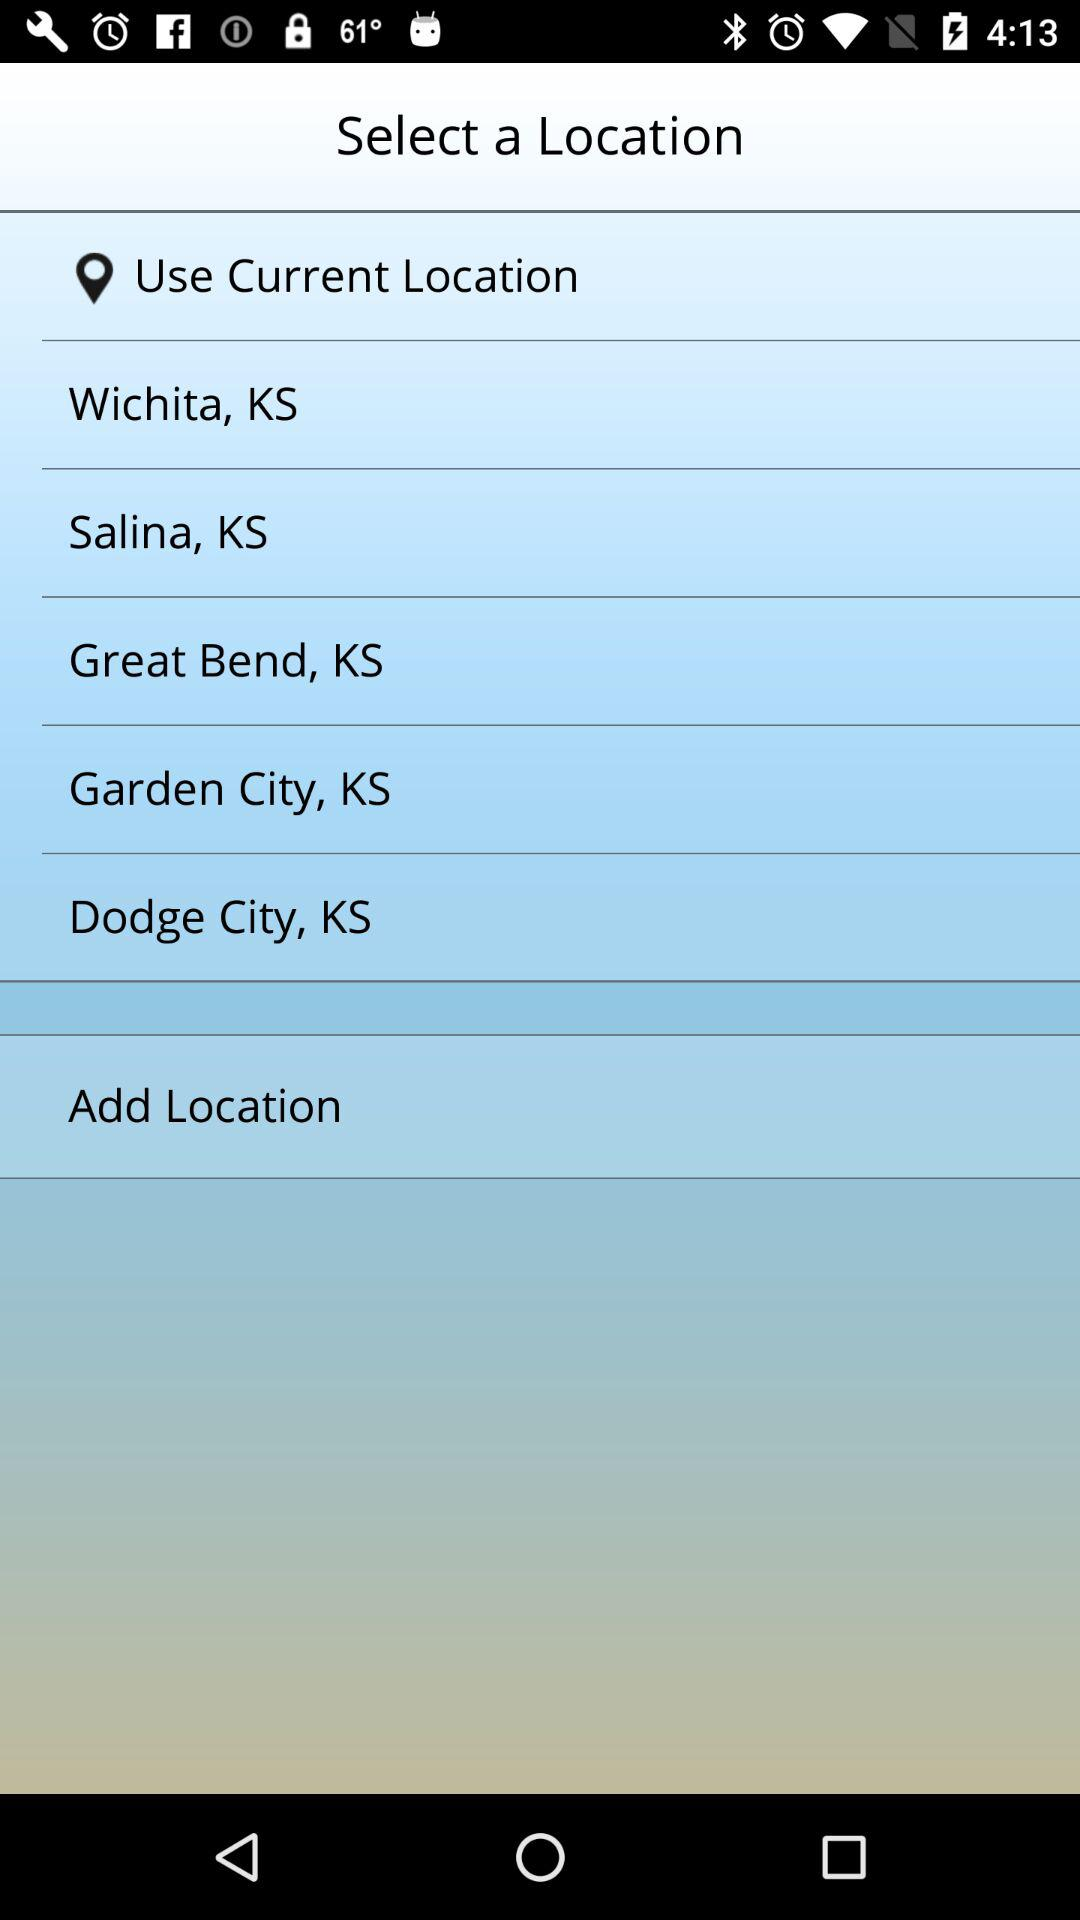What is the current location?
When the provided information is insufficient, respond with <no answer>. <no answer> 